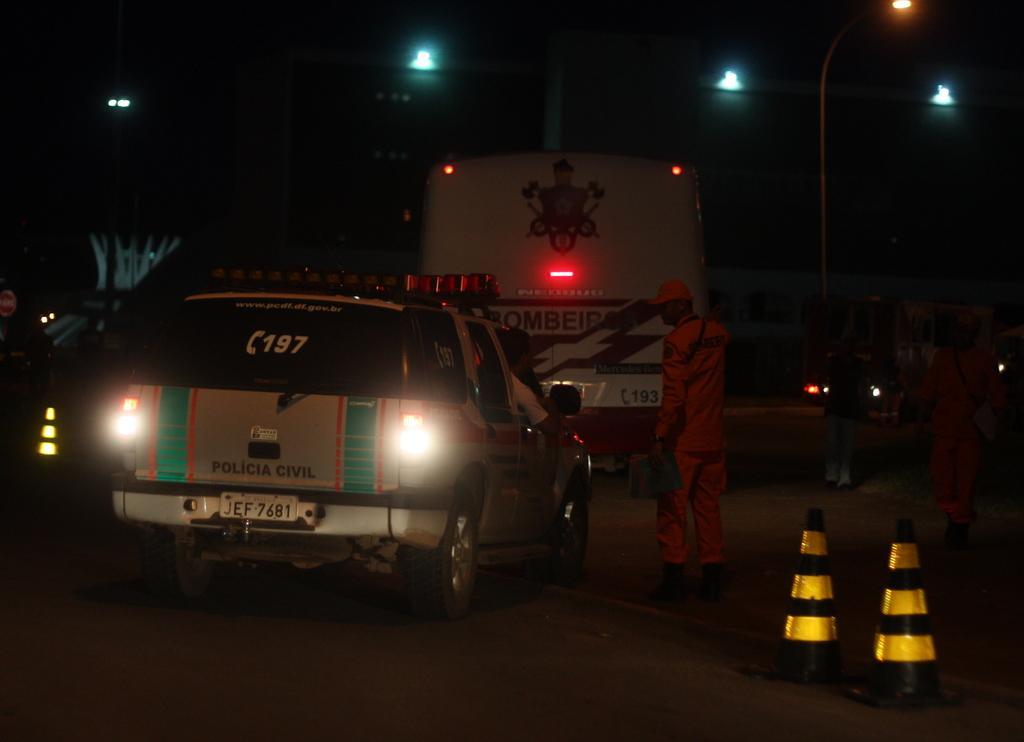Can you describe this image briefly? In the middle of the image there are some vehicles on the road and few people are standing and there are some road divider cones. Behind them there are some poles and lights. 